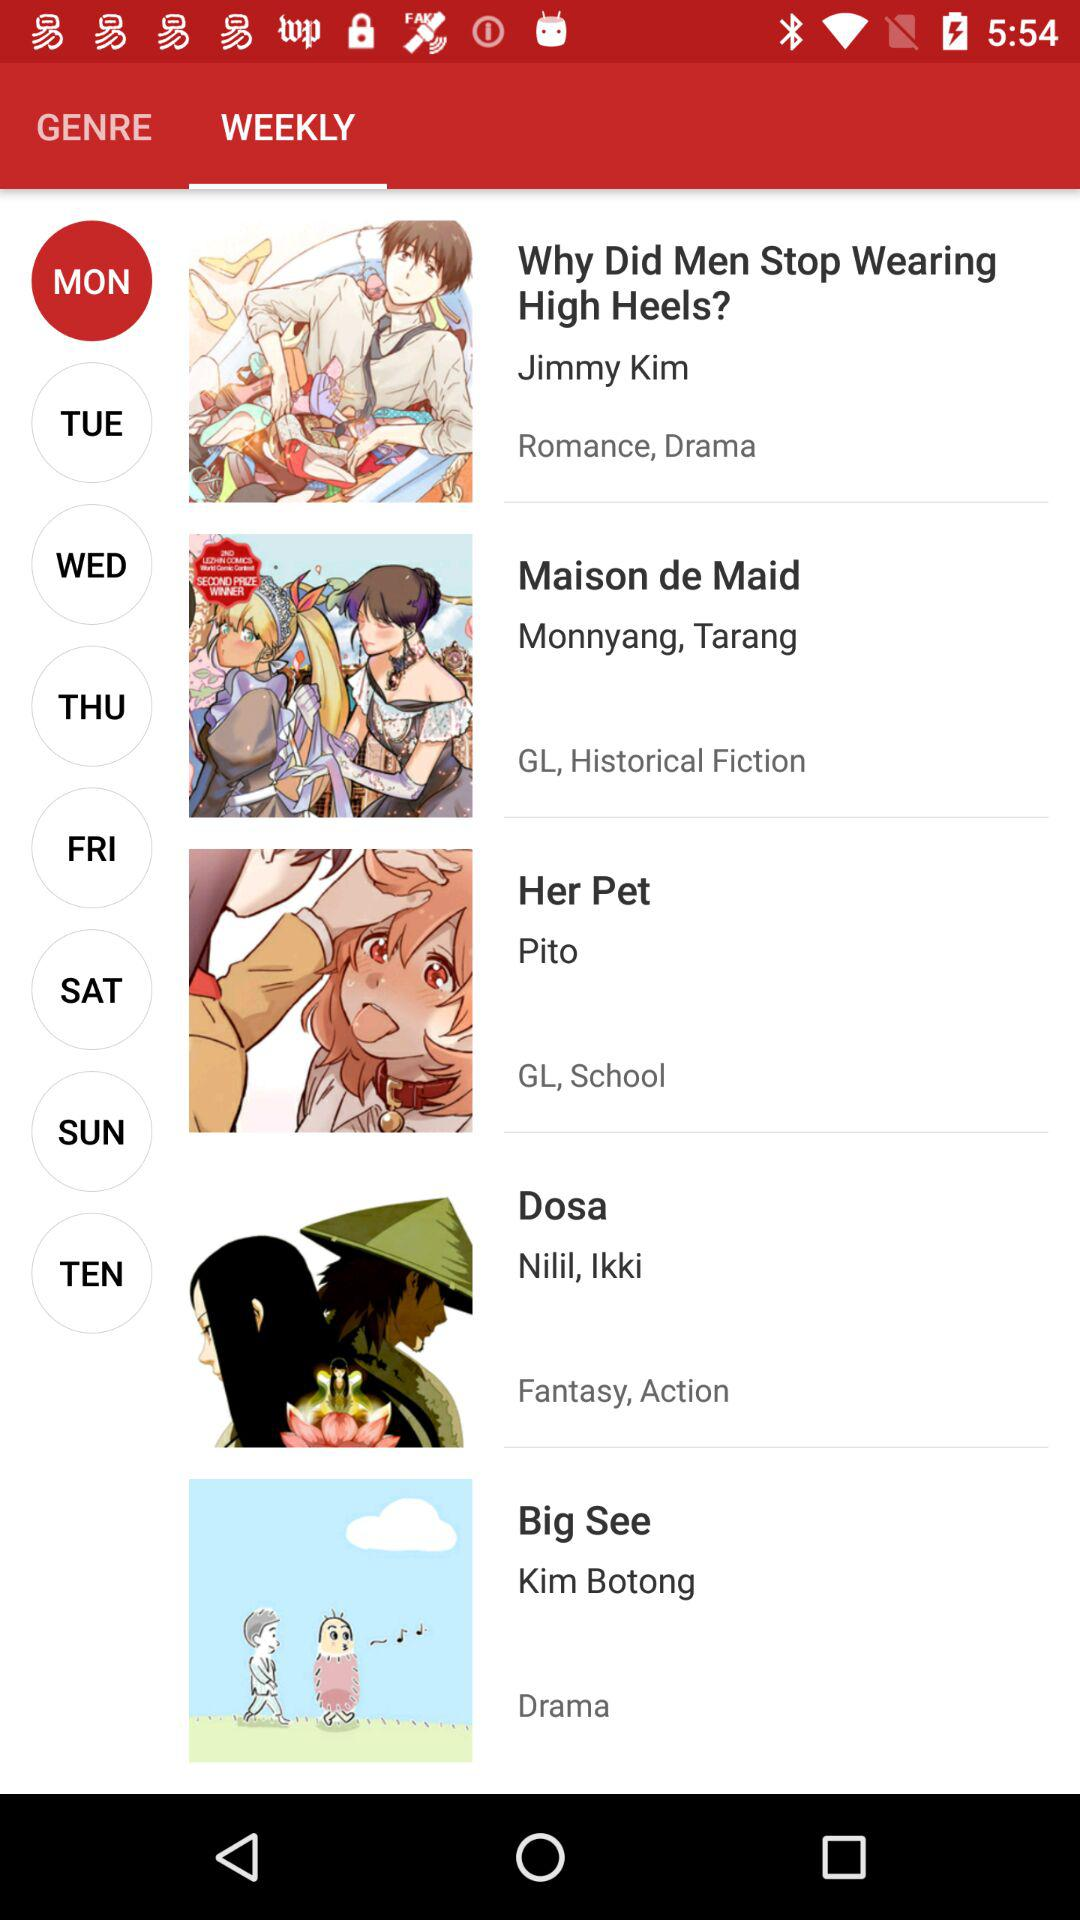What is the genre of the "Dosa" webtoon? The genres are fantasy and action. 